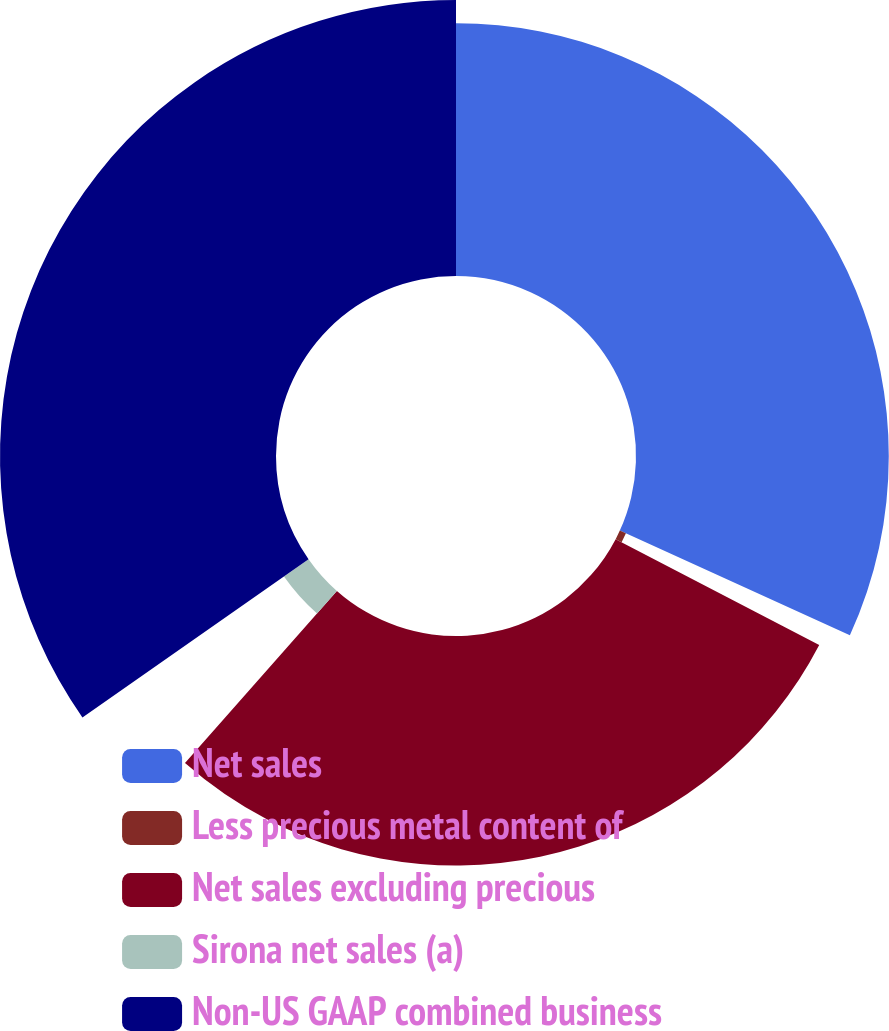Convert chart to OTSL. <chart><loc_0><loc_0><loc_500><loc_500><pie_chart><fcel>Net sales<fcel>Less precious metal content of<fcel>Net sales excluding precious<fcel>Sirona net sales (a)<fcel>Non-US GAAP combined business<nl><fcel>31.8%<fcel>0.84%<fcel>28.87%<fcel>3.77%<fcel>34.72%<nl></chart> 